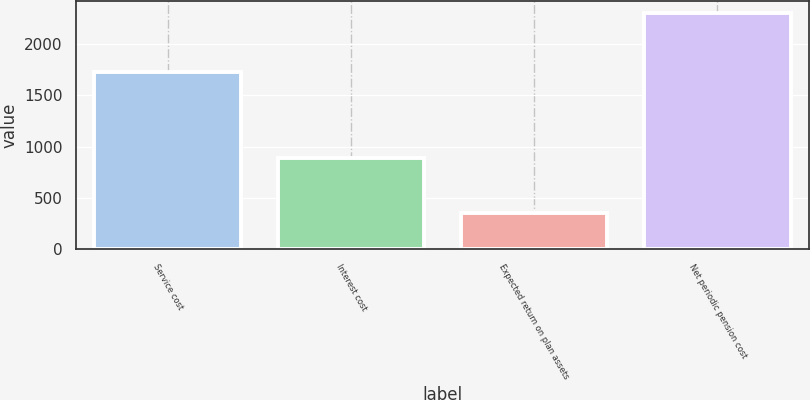Convert chart. <chart><loc_0><loc_0><loc_500><loc_500><bar_chart><fcel>Service cost<fcel>Interest cost<fcel>Expected return on plan assets<fcel>Net periodic pension cost<nl><fcel>1726<fcel>886<fcel>354<fcel>2302<nl></chart> 